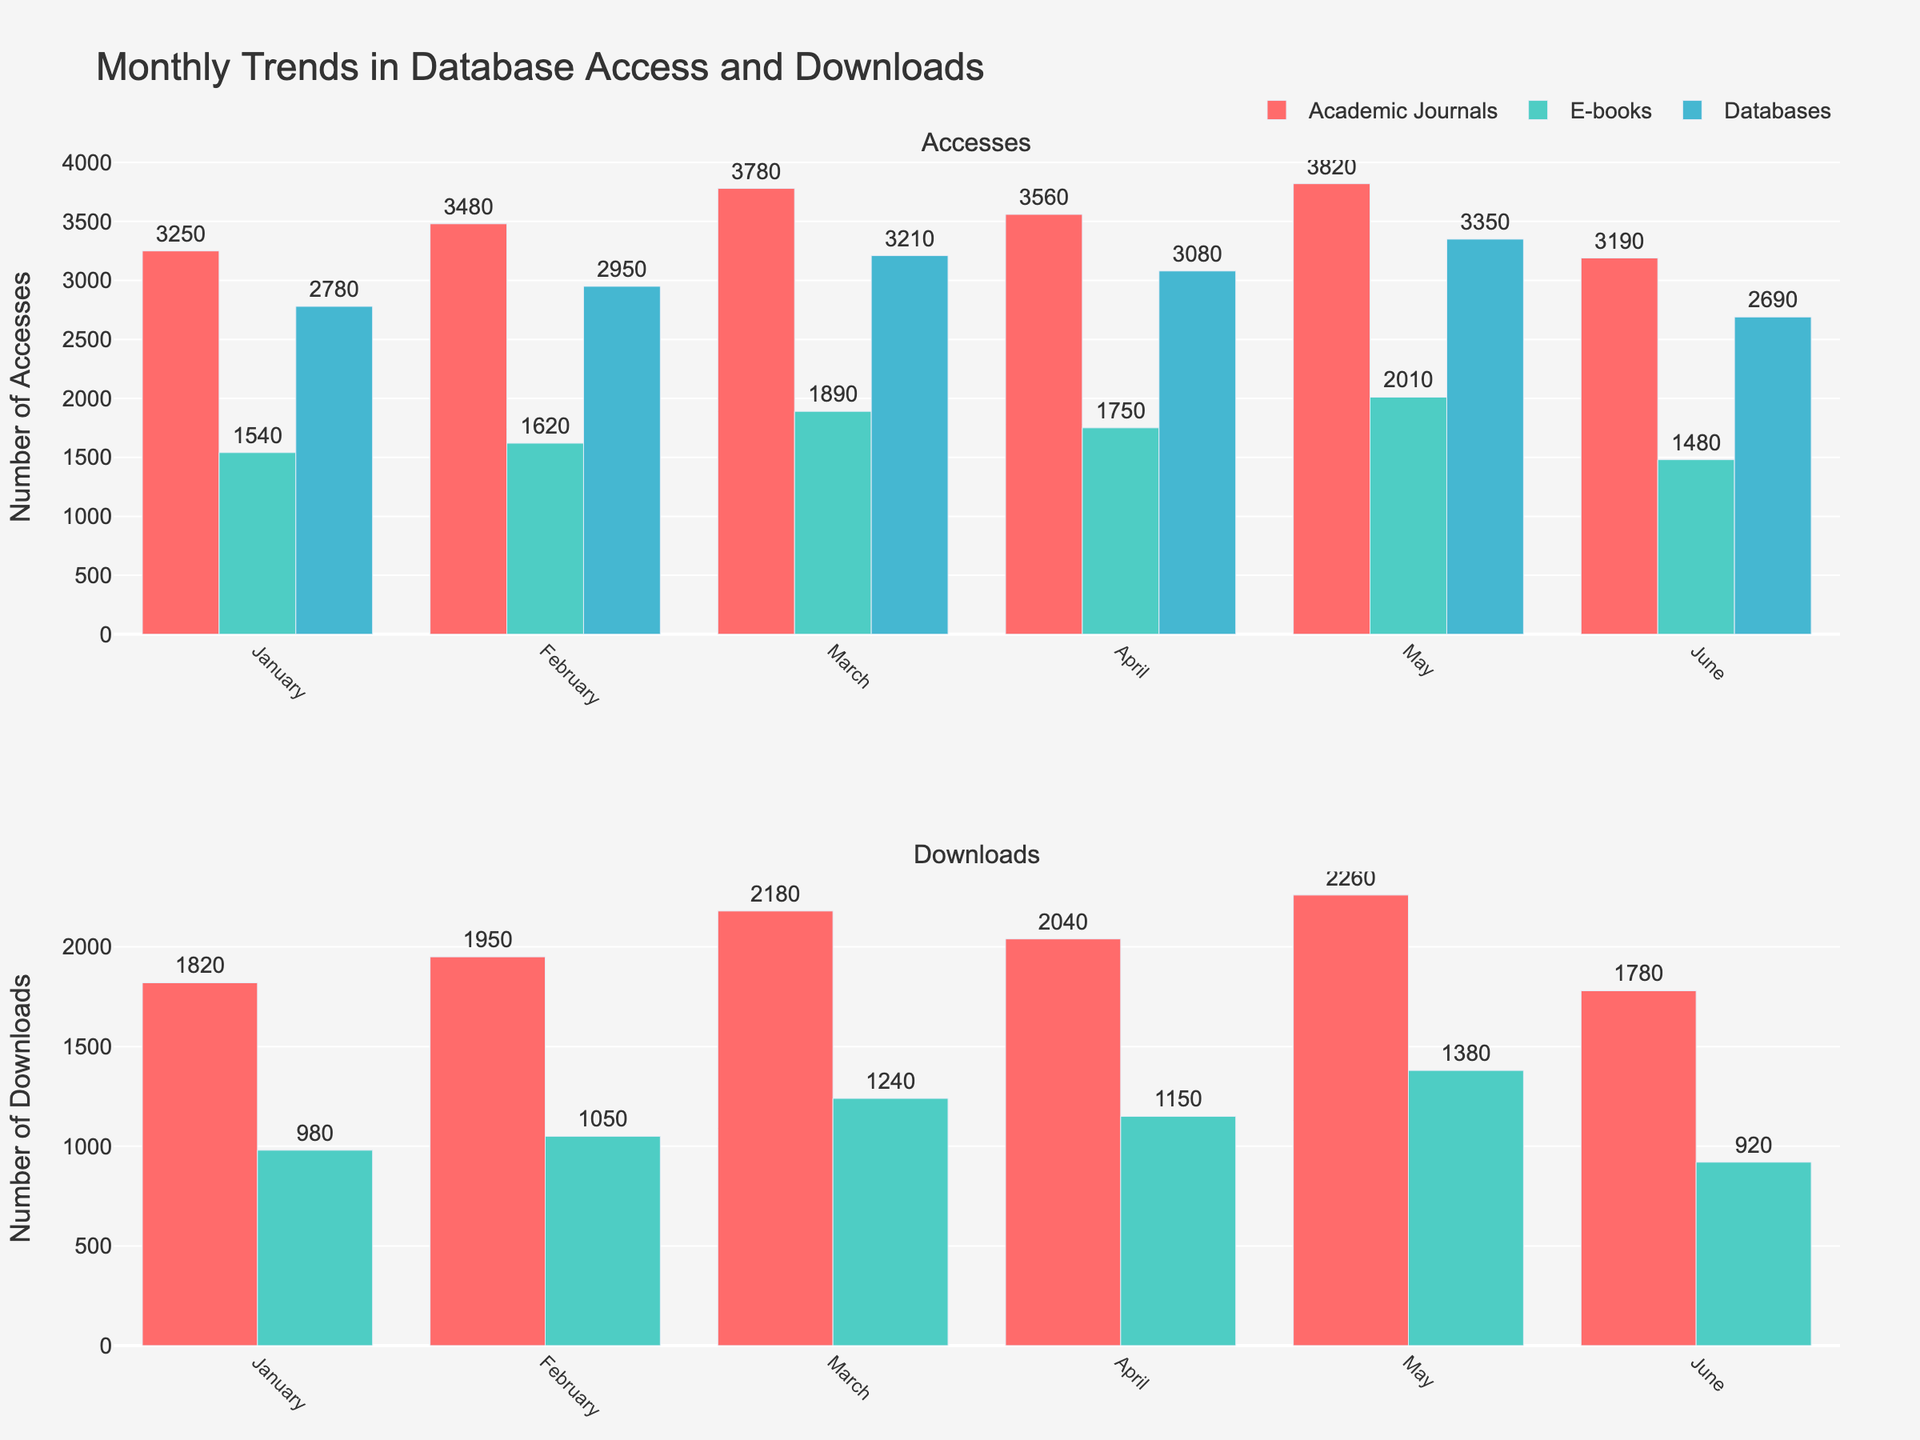what are the titles of the subplots? The subplots have individual titles 'Accesses' and 'Downloads'. These titles are displayed above each respective subplot in the figure.
Answer: Accesses and Downloads Which resource type has the highest number of accesses in May? Look at the 'Accesses' subplot for the month of May and identify the tallest bar. The tallest bar in May corresponds to 'Academic Journals' whose height represents the highest number of accesses.
Answer: Academic Journals How many more accesses did E-books have in March compared to February? Locate the bars for E-books in March and February in the 'Accesses' subplot, read their heights (March: 1890, February: 1620), then subtract the February value from the March value.
Answer: 270 What is the total number of downloads for Academic Journals in the first quarter (January-March)? Sum the download values from the 'Downloads' subplot for Academic Journals in January (1820), February (1950), and March (2180). Add these values together.
Answer: 5950 Which resource type shows a decrease in accesses from May to June? Compare the heights of the bars for each resource type between May and June in the 'Accesses' subplot. Identify the resource type where the bar is shorter in June than in May.
Answer: Academic Journals What is the average number of accesses per month for Databases across the six months? Sum the monthly accesses for Databases and divide by the number of months. The values are: (2780 + 2950 + 3210 + 3080 + 3350 + 2690). Total = 18060. Divide by 6.
Answer: 3010 How many downloads did E-books have in total from January to June? Add the download values for E-books from January to June as shown in the 'Downloads' subplot. The values are: (980 + 1050 + 1240 + 1150 + 1380 + 920). Total = 6720.
Answer: 6720 Which month had the highest number of accesses for Academic Journals? In the 'Accesses' subplot, find the tallest bar for Academic Journals and identify the corresponding month.
Answer: May Did the number of downloads for E-books reach its peak in June? Check the 'Downloads' subplot for the height of the E-books bar in June and compare it with the previous months. March has a higher bar than June.
Answer: No Which resource type does not have any download data? In the 'Downloads' subplot, identify the resource type that has no bars represented.
Answer: Databases 